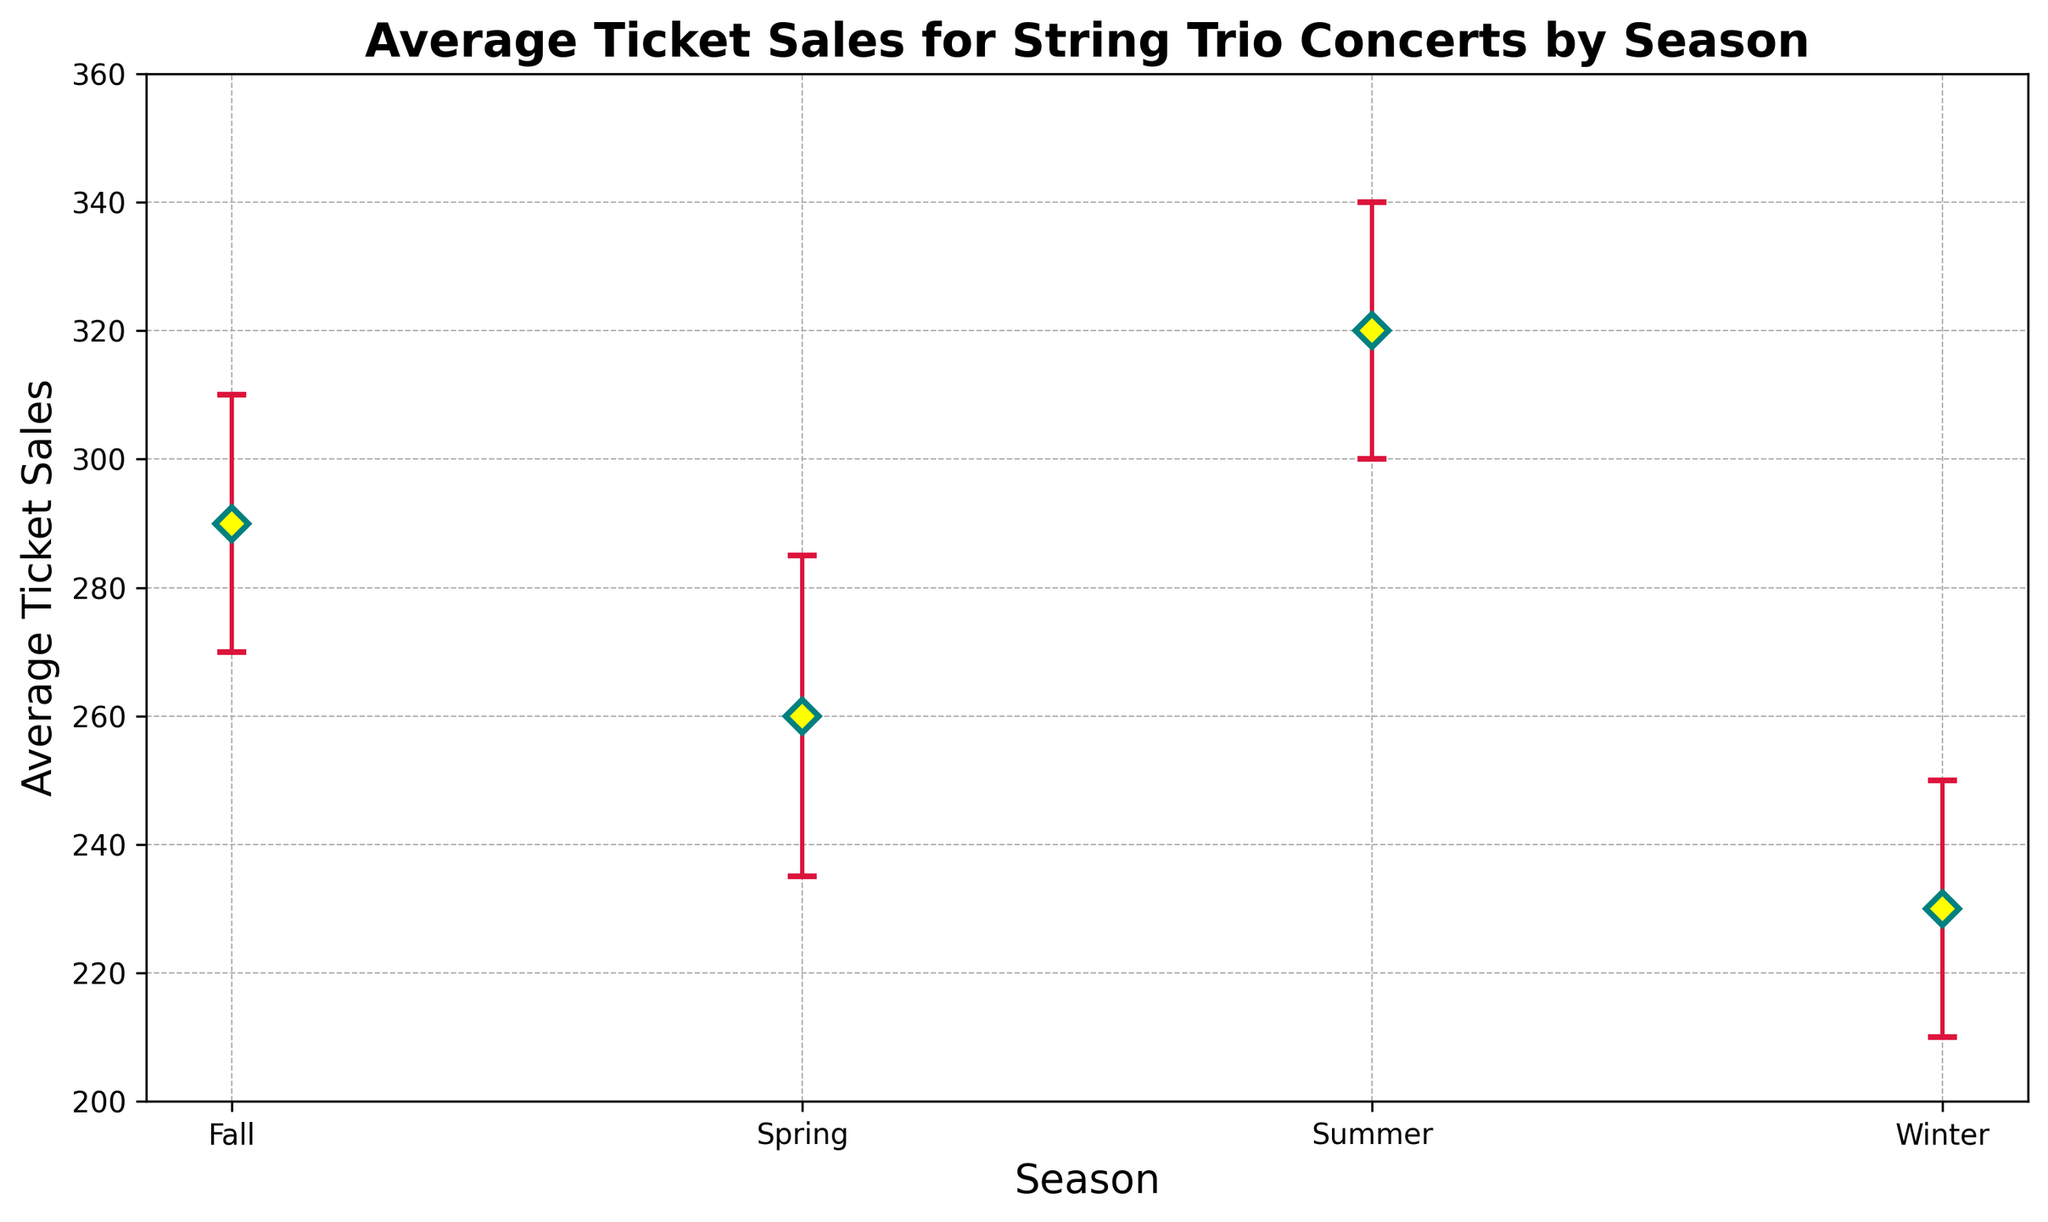What is the season with the highest average ticket sales? The figure shows the average ticket sales for each season with the average for Summer being the highest.
Answer: Summer During which season do average ticket sales vary the least, considering the confidence intervals? The tightest error bars represent less variation. Winter shows the least variation with error bars being smallest.
Answer: Winter What is the difference in average ticket sales between Summer and Winter? The average ticket sales in Summer are around 320, and in Winter, it's roughly 230. The difference is 320 - 230 = 90.
Answer: 90 Which season shows the widest confidence interval? The confidence interval for the Summer season appears widest compared to others; the range stretches from 290 to 350.
Answer: Summer What is the approximate range of average ticket sales during Fall? In Fall, the confidence intervals stretch from roughly 270 to 310, making the range 310 - 270 = 40.
Answer: 40 